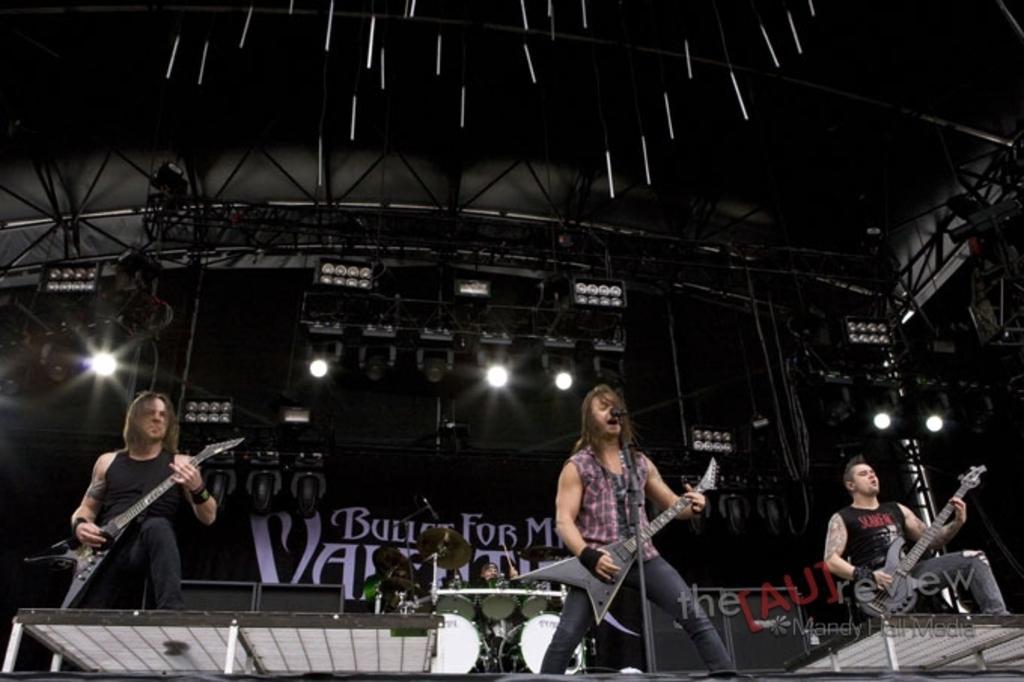Can you describe this image briefly? These three persons are standing and holding guitar. This person singing. On the background we can see focusing light. There is a person playing musical instrument. 